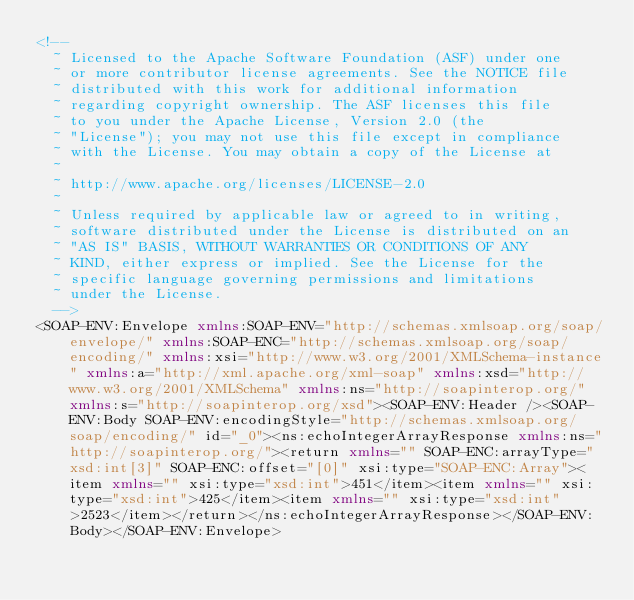Convert code to text. <code><loc_0><loc_0><loc_500><loc_500><_XML_><!--
  ~ Licensed to the Apache Software Foundation (ASF) under one
  ~ or more contributor license agreements. See the NOTICE file
  ~ distributed with this work for additional information
  ~ regarding copyright ownership. The ASF licenses this file
  ~ to you under the Apache License, Version 2.0 (the
  ~ "License"); you may not use this file except in compliance
  ~ with the License. You may obtain a copy of the License at
  ~
  ~ http://www.apache.org/licenses/LICENSE-2.0
  ~
  ~ Unless required by applicable law or agreed to in writing,
  ~ software distributed under the License is distributed on an
  ~ "AS IS" BASIS, WITHOUT WARRANTIES OR CONDITIONS OF ANY
  ~ KIND, either express or implied. See the License for the
  ~ specific language governing permissions and limitations
  ~ under the License.
  -->
<SOAP-ENV:Envelope xmlns:SOAP-ENV="http://schemas.xmlsoap.org/soap/envelope/" xmlns:SOAP-ENC="http://schemas.xmlsoap.org/soap/encoding/" xmlns:xsi="http://www.w3.org/2001/XMLSchema-instance" xmlns:a="http://xml.apache.org/xml-soap" xmlns:xsd="http://www.w3.org/2001/XMLSchema" xmlns:ns="http://soapinterop.org/" xmlns:s="http://soapinterop.org/xsd"><SOAP-ENV:Header /><SOAP-ENV:Body SOAP-ENV:encodingStyle="http://schemas.xmlsoap.org/soap/encoding/" id="_0"><ns:echoIntegerArrayResponse xmlns:ns="http://soapinterop.org/"><return xmlns="" SOAP-ENC:arrayType="xsd:int[3]" SOAP-ENC:offset="[0]" xsi:type="SOAP-ENC:Array"><item xmlns="" xsi:type="xsd:int">451</item><item xmlns="" xsi:type="xsd:int">425</item><item xmlns="" xsi:type="xsd:int">2523</item></return></ns:echoIntegerArrayResponse></SOAP-ENV:Body></SOAP-ENV:Envelope></code> 